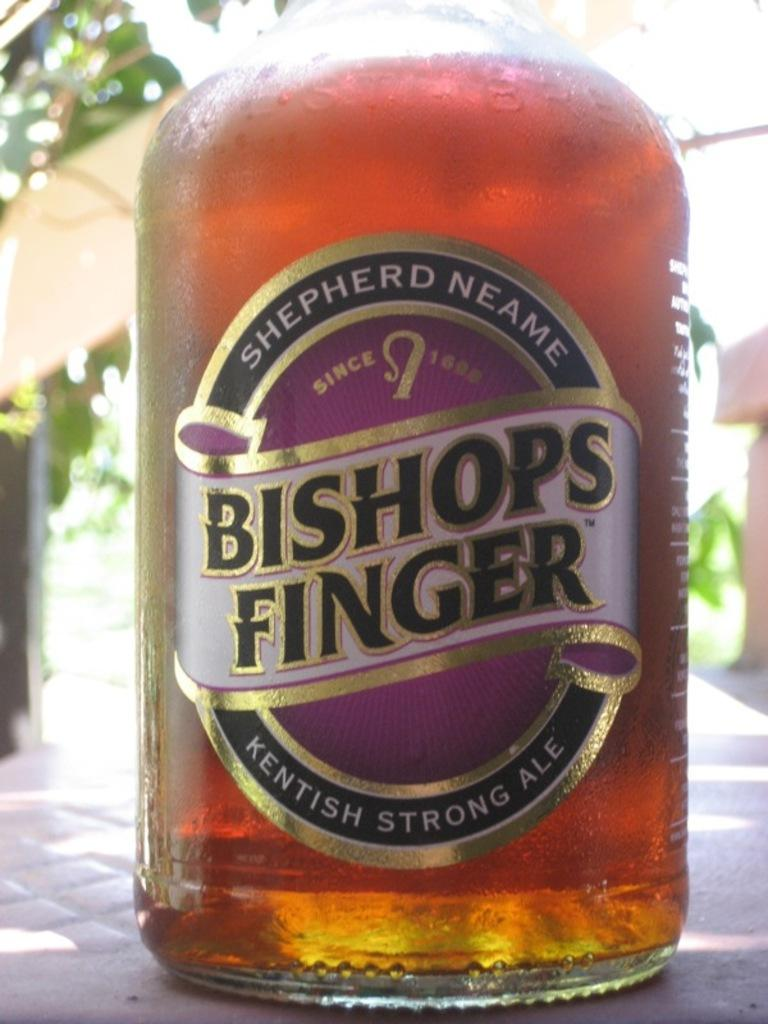<image>
Render a clear and concise summary of the photo. A large bottle of SHEPHERD NEAME BISHOPS FINGER KENTISH STRONG ALE. 